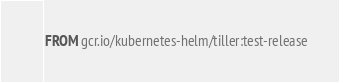Convert code to text. <code><loc_0><loc_0><loc_500><loc_500><_Dockerfile_>FROM gcr.io/kubernetes-helm/tiller:test-release
</code> 